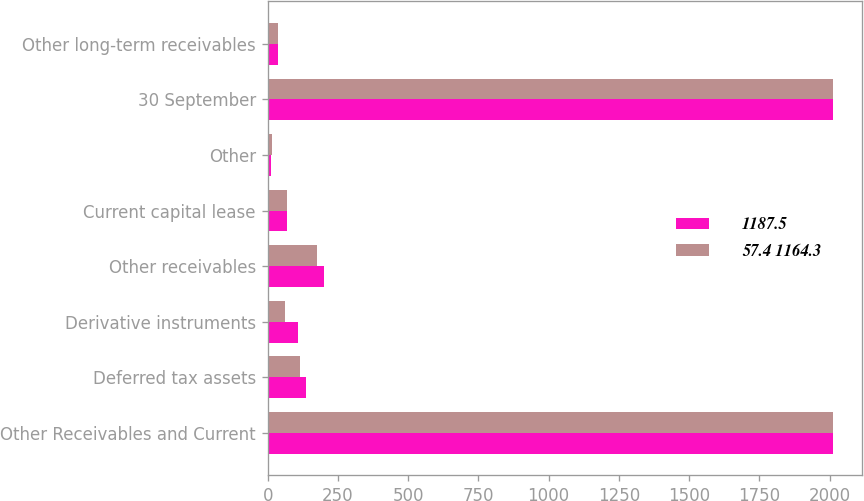Convert chart to OTSL. <chart><loc_0><loc_0><loc_500><loc_500><stacked_bar_chart><ecel><fcel>Other Receivables and Current<fcel>Deferred tax assets<fcel>Derivative instruments<fcel>Other receivables<fcel>Current capital lease<fcel>Other<fcel>30 September<fcel>Other long-term receivables<nl><fcel>1187.5<fcel>2014<fcel>136<fcel>106.6<fcel>200<fcel>67.8<fcel>12.6<fcel>2014<fcel>35.1<nl><fcel>57.4 1164.3<fcel>2013<fcel>115.3<fcel>61.8<fcel>174.1<fcel>67.2<fcel>14<fcel>2013<fcel>38.2<nl></chart> 